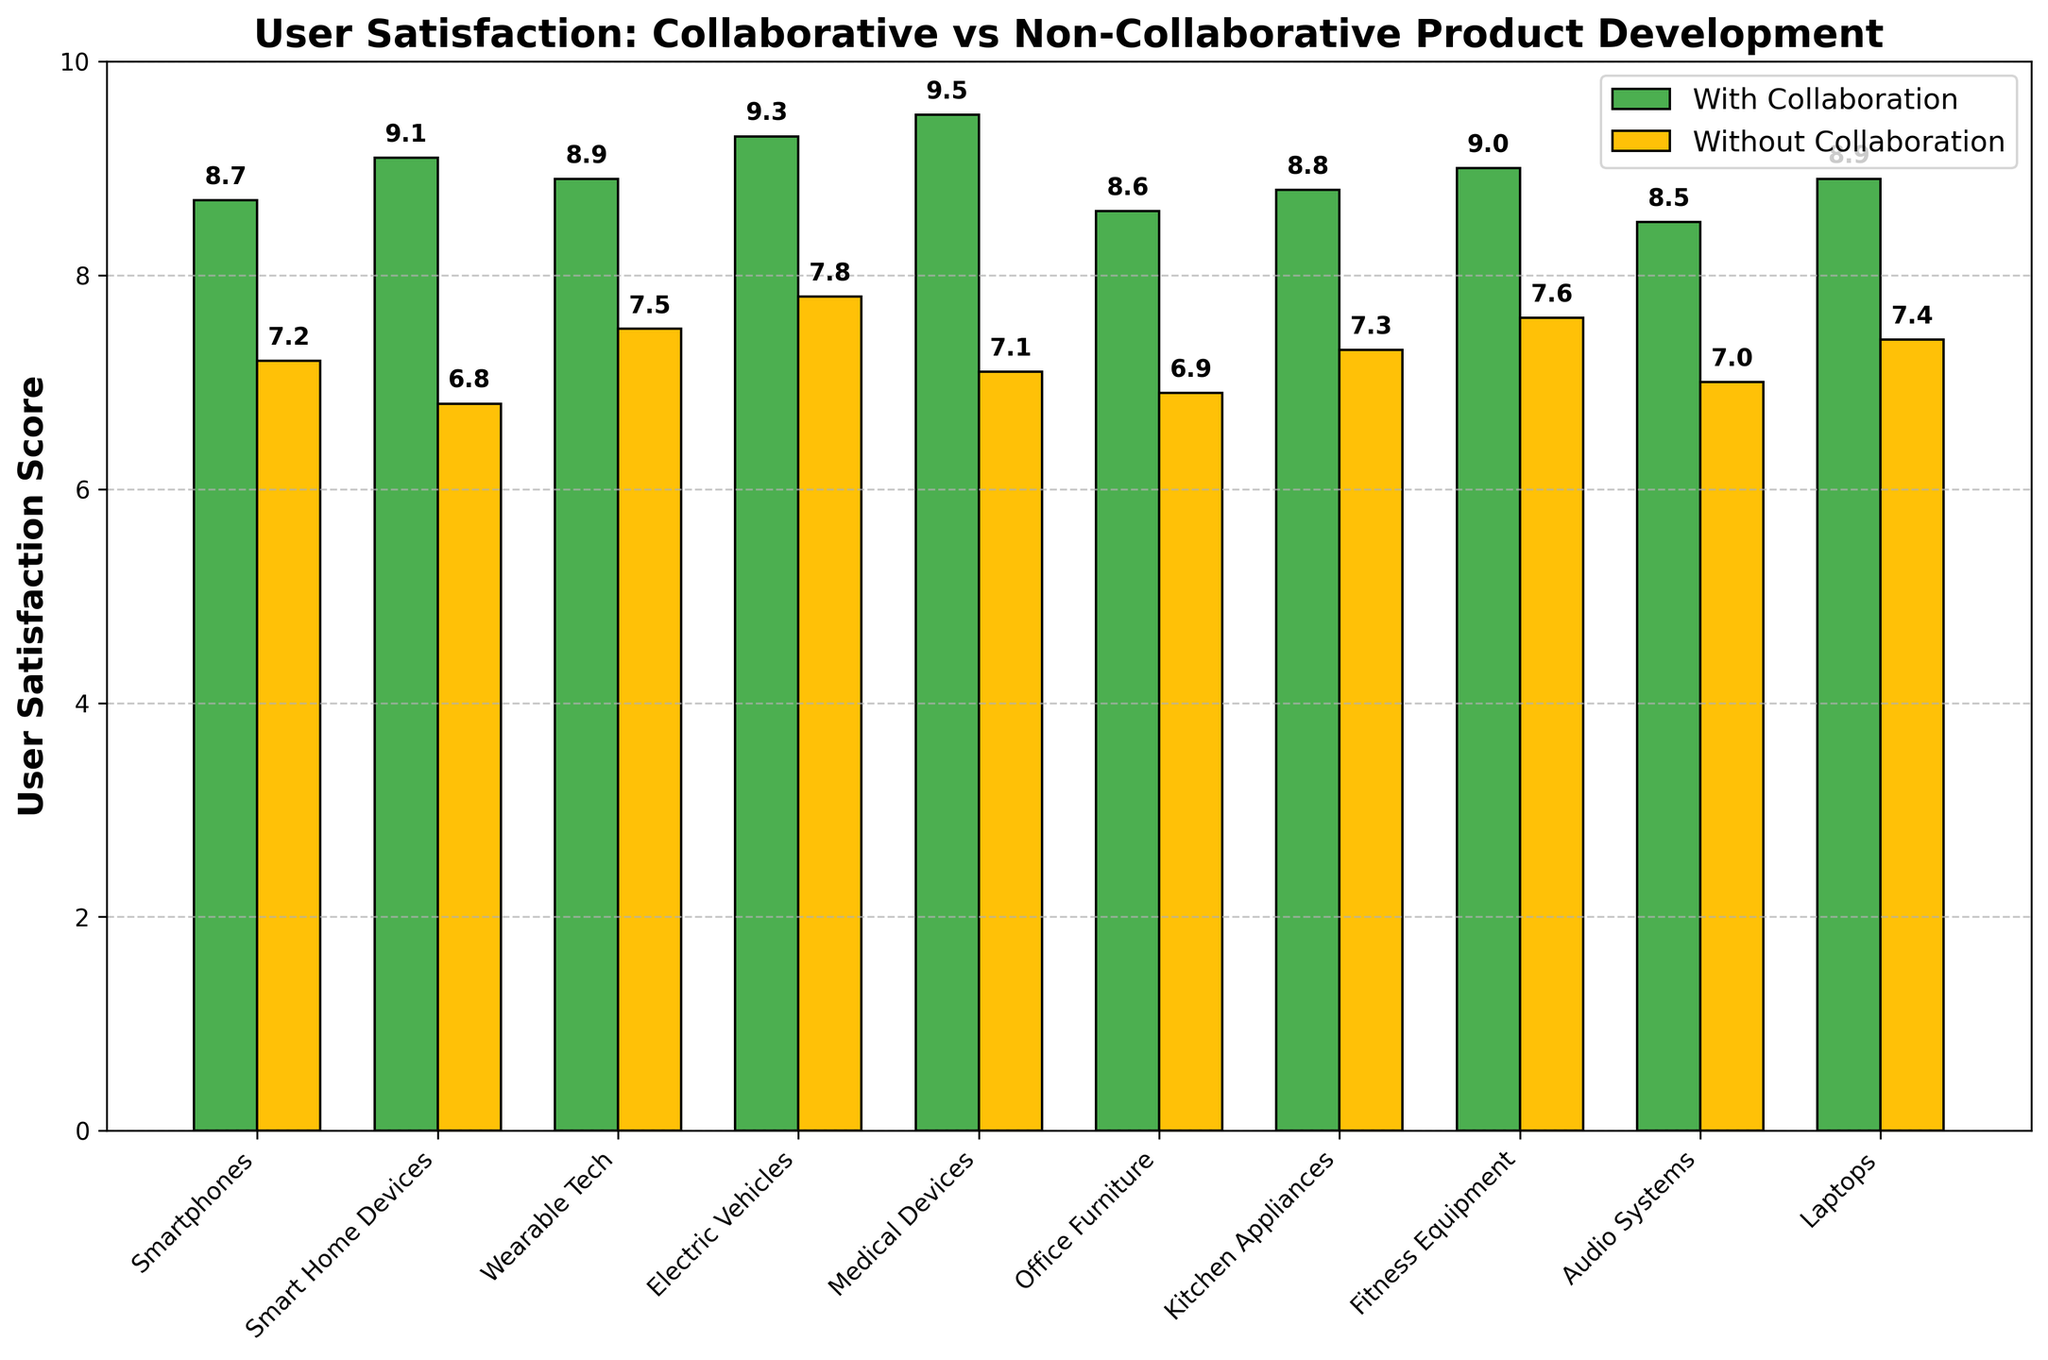What is the highest user satisfaction score for products developed with interdisciplinary collaboration? The highest user satisfaction score with collaboration is identified by checking the highest value among the "With Collaboration" bar heights. The highest value is 9.5 for Medical Devices.
Answer: 9.5 Which product category has the largest difference in user satisfaction scores between collaborative and non-collaborative development? Subtract the "Without Collaboration" score from the "With Collaboration" score for each product category, and identify the maximum difference. Medical Devices have a difference of 2.4 (9.5 - 7.1).
Answer: Medical Devices How many product categories have a user satisfaction score of 8.9 with interdisciplinary collaboration? Identify and count the bars labeled "With Collaboration" that have a height of 8.9. These are Wearable Tech and Laptops.
Answer: 2 Which product category shows the smallest improvement in user satisfaction when developed with interdisciplinary collaboration? Subtract the "Without Collaboration" score from the “With Collaboration" score for each product, and identify the minimum positive difference. Audio Systems have the smallest difference of 1.5 (8.5 - 7.0).
Answer: Audio Systems What is the average user satisfaction score for products developed without interdisciplinary collaboration? Add up all the "Without Collaboration" scores and divide by the number of products. Sum: 7.2 + 6.8 + 7.5 + 7.8 + 7.1 + 6.9 + 7.3 + 7.6 + 7.0 + 7.4 = 72.6. Divide by 10 = 7.26.
Answer: 7.26 How many products have a higher satisfaction score with collaboration compared to without collaboration? Count the number of products where the "With Collaboration" bar is taller than the "Without Collaboration" bar. All 10 products fit this description.
Answer: 10 Which product has the lowest user satisfaction score without collaboration, and what is that score? Identify and read the shortest "Without Collaboration" bar. Smart Home Devices have the lowest score of 6.8.
Answer: Smart Home Devices, 6.8 What color represents products developed without interdisciplinary collaboration in the chart? Identify the color of the bars labeled "Without Collaboration". They are yellow.
Answer: Yellow 